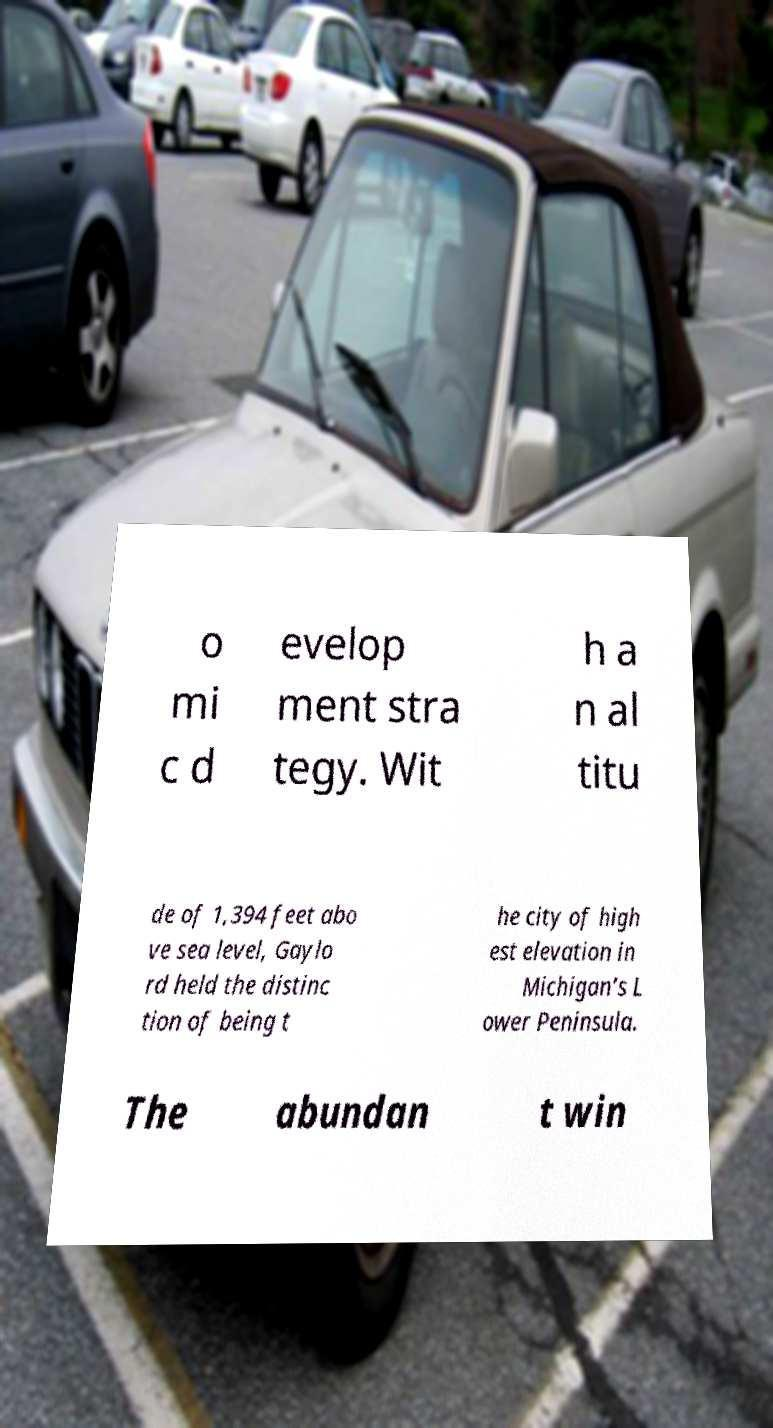Can you accurately transcribe the text from the provided image for me? o mi c d evelop ment stra tegy. Wit h a n al titu de of 1,394 feet abo ve sea level, Gaylo rd held the distinc tion of being t he city of high est elevation in Michigan’s L ower Peninsula. The abundan t win 